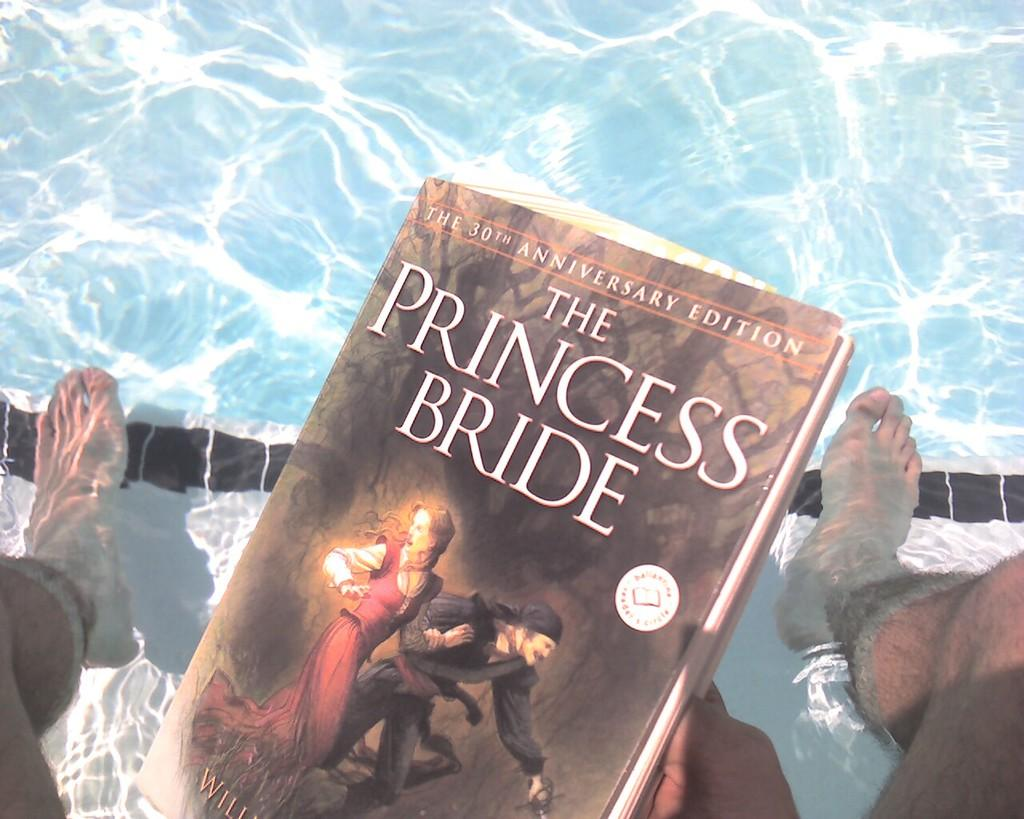Who or what is present in the image? There is a person in the image. What is the person holding? The person is holding a book. What can be found inside the book? The book contains text and images of two persons. What can be seen in the background of the image? There is water and a floor visible in the image. What type of thread is being used to sew the glass in the image? There is no thread or glass present in the image. 